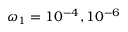<formula> <loc_0><loc_0><loc_500><loc_500>\omega _ { 1 } = 1 0 ^ { - 4 } , 1 0 ^ { - 6 }</formula> 